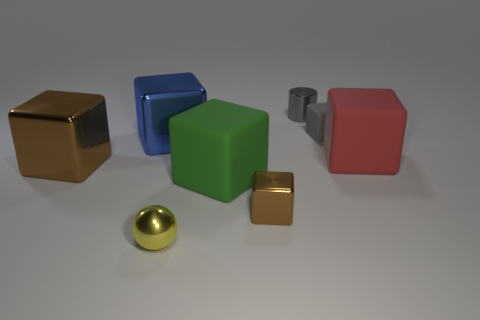Subtract all big red blocks. How many blocks are left? 5 Subtract all gray cubes. How many cubes are left? 5 Subtract all cubes. How many objects are left? 2 Add 2 matte cubes. How many objects exist? 10 Subtract 1 balls. How many balls are left? 0 Subtract all cyan balls. How many green cubes are left? 1 Add 8 big brown objects. How many big brown objects are left? 9 Add 1 large brown objects. How many large brown objects exist? 2 Subtract 0 red spheres. How many objects are left? 8 Subtract all green blocks. Subtract all brown cylinders. How many blocks are left? 5 